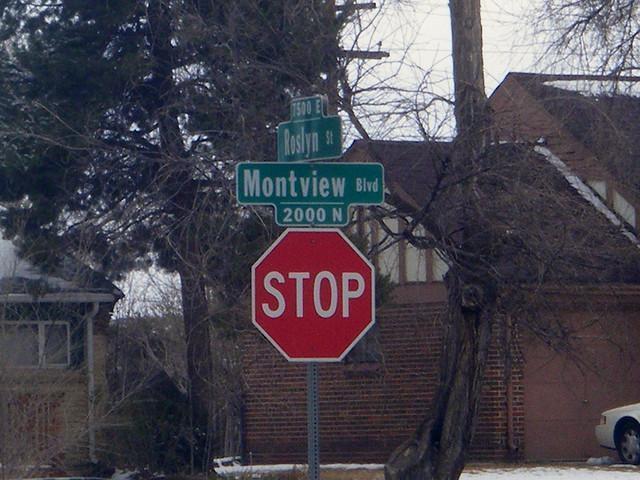How many people are in this scene?
Give a very brief answer. 0. 